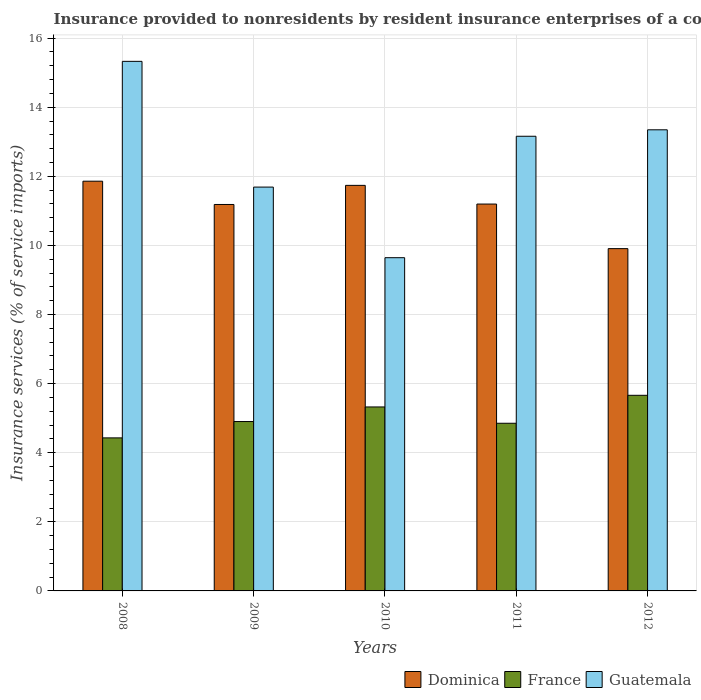How many different coloured bars are there?
Your answer should be compact. 3. How many groups of bars are there?
Provide a short and direct response. 5. Are the number of bars per tick equal to the number of legend labels?
Ensure brevity in your answer.  Yes. Are the number of bars on each tick of the X-axis equal?
Ensure brevity in your answer.  Yes. What is the insurance provided to nonresidents in Guatemala in 2008?
Make the answer very short. 15.33. Across all years, what is the maximum insurance provided to nonresidents in Dominica?
Provide a succinct answer. 11.86. Across all years, what is the minimum insurance provided to nonresidents in France?
Offer a very short reply. 4.43. In which year was the insurance provided to nonresidents in Guatemala maximum?
Your answer should be compact. 2008. In which year was the insurance provided to nonresidents in Dominica minimum?
Offer a very short reply. 2012. What is the total insurance provided to nonresidents in Dominica in the graph?
Your answer should be compact. 55.89. What is the difference between the insurance provided to nonresidents in Dominica in 2008 and that in 2011?
Your answer should be very brief. 0.66. What is the difference between the insurance provided to nonresidents in Dominica in 2008 and the insurance provided to nonresidents in Guatemala in 2012?
Provide a succinct answer. -1.49. What is the average insurance provided to nonresidents in Guatemala per year?
Your answer should be compact. 12.63. In the year 2010, what is the difference between the insurance provided to nonresidents in France and insurance provided to nonresidents in Dominica?
Provide a succinct answer. -6.41. What is the ratio of the insurance provided to nonresidents in Guatemala in 2011 to that in 2012?
Your response must be concise. 0.99. What is the difference between the highest and the second highest insurance provided to nonresidents in Dominica?
Offer a very short reply. 0.12. What is the difference between the highest and the lowest insurance provided to nonresidents in Guatemala?
Offer a terse response. 5.68. In how many years, is the insurance provided to nonresidents in Guatemala greater than the average insurance provided to nonresidents in Guatemala taken over all years?
Keep it short and to the point. 3. Is the sum of the insurance provided to nonresidents in Dominica in 2008 and 2011 greater than the maximum insurance provided to nonresidents in Guatemala across all years?
Give a very brief answer. Yes. What does the 3rd bar from the left in 2011 represents?
Your answer should be very brief. Guatemala. What does the 3rd bar from the right in 2011 represents?
Provide a short and direct response. Dominica. How many bars are there?
Offer a very short reply. 15. What is the difference between two consecutive major ticks on the Y-axis?
Make the answer very short. 2. Are the values on the major ticks of Y-axis written in scientific E-notation?
Keep it short and to the point. No. Does the graph contain any zero values?
Give a very brief answer. No. Where does the legend appear in the graph?
Your answer should be very brief. Bottom right. How many legend labels are there?
Your answer should be compact. 3. What is the title of the graph?
Your answer should be very brief. Insurance provided to nonresidents by resident insurance enterprises of a country. Does "Philippines" appear as one of the legend labels in the graph?
Offer a terse response. No. What is the label or title of the Y-axis?
Keep it short and to the point. Insurance services (% of service imports). What is the Insurance services (% of service imports) of Dominica in 2008?
Your response must be concise. 11.86. What is the Insurance services (% of service imports) of France in 2008?
Your answer should be very brief. 4.43. What is the Insurance services (% of service imports) of Guatemala in 2008?
Your response must be concise. 15.33. What is the Insurance services (% of service imports) of Dominica in 2009?
Your response must be concise. 11.19. What is the Insurance services (% of service imports) of France in 2009?
Provide a succinct answer. 4.9. What is the Insurance services (% of service imports) in Guatemala in 2009?
Offer a very short reply. 11.69. What is the Insurance services (% of service imports) of Dominica in 2010?
Make the answer very short. 11.74. What is the Insurance services (% of service imports) of France in 2010?
Your answer should be very brief. 5.32. What is the Insurance services (% of service imports) of Guatemala in 2010?
Ensure brevity in your answer.  9.65. What is the Insurance services (% of service imports) of Dominica in 2011?
Your response must be concise. 11.2. What is the Insurance services (% of service imports) of France in 2011?
Your answer should be very brief. 4.85. What is the Insurance services (% of service imports) in Guatemala in 2011?
Make the answer very short. 13.16. What is the Insurance services (% of service imports) in Dominica in 2012?
Offer a terse response. 9.91. What is the Insurance services (% of service imports) of France in 2012?
Keep it short and to the point. 5.66. What is the Insurance services (% of service imports) in Guatemala in 2012?
Ensure brevity in your answer.  13.35. Across all years, what is the maximum Insurance services (% of service imports) in Dominica?
Your response must be concise. 11.86. Across all years, what is the maximum Insurance services (% of service imports) in France?
Provide a succinct answer. 5.66. Across all years, what is the maximum Insurance services (% of service imports) of Guatemala?
Your answer should be very brief. 15.33. Across all years, what is the minimum Insurance services (% of service imports) in Dominica?
Your answer should be very brief. 9.91. Across all years, what is the minimum Insurance services (% of service imports) of France?
Your answer should be compact. 4.43. Across all years, what is the minimum Insurance services (% of service imports) of Guatemala?
Your answer should be compact. 9.65. What is the total Insurance services (% of service imports) in Dominica in the graph?
Give a very brief answer. 55.89. What is the total Insurance services (% of service imports) of France in the graph?
Ensure brevity in your answer.  25.17. What is the total Insurance services (% of service imports) in Guatemala in the graph?
Offer a terse response. 63.17. What is the difference between the Insurance services (% of service imports) in Dominica in 2008 and that in 2009?
Offer a very short reply. 0.67. What is the difference between the Insurance services (% of service imports) in France in 2008 and that in 2009?
Make the answer very short. -0.47. What is the difference between the Insurance services (% of service imports) in Guatemala in 2008 and that in 2009?
Provide a succinct answer. 3.64. What is the difference between the Insurance services (% of service imports) of Dominica in 2008 and that in 2010?
Your answer should be compact. 0.12. What is the difference between the Insurance services (% of service imports) of France in 2008 and that in 2010?
Provide a short and direct response. -0.9. What is the difference between the Insurance services (% of service imports) in Guatemala in 2008 and that in 2010?
Offer a terse response. 5.68. What is the difference between the Insurance services (% of service imports) in Dominica in 2008 and that in 2011?
Offer a very short reply. 0.66. What is the difference between the Insurance services (% of service imports) of France in 2008 and that in 2011?
Keep it short and to the point. -0.42. What is the difference between the Insurance services (% of service imports) in Guatemala in 2008 and that in 2011?
Your answer should be compact. 2.17. What is the difference between the Insurance services (% of service imports) in Dominica in 2008 and that in 2012?
Offer a very short reply. 1.95. What is the difference between the Insurance services (% of service imports) of France in 2008 and that in 2012?
Make the answer very short. -1.23. What is the difference between the Insurance services (% of service imports) in Guatemala in 2008 and that in 2012?
Give a very brief answer. 1.98. What is the difference between the Insurance services (% of service imports) of Dominica in 2009 and that in 2010?
Provide a short and direct response. -0.55. What is the difference between the Insurance services (% of service imports) in France in 2009 and that in 2010?
Offer a very short reply. -0.42. What is the difference between the Insurance services (% of service imports) in Guatemala in 2009 and that in 2010?
Your response must be concise. 2.04. What is the difference between the Insurance services (% of service imports) of Dominica in 2009 and that in 2011?
Your response must be concise. -0.01. What is the difference between the Insurance services (% of service imports) in France in 2009 and that in 2011?
Make the answer very short. 0.05. What is the difference between the Insurance services (% of service imports) in Guatemala in 2009 and that in 2011?
Give a very brief answer. -1.47. What is the difference between the Insurance services (% of service imports) in Dominica in 2009 and that in 2012?
Offer a very short reply. 1.28. What is the difference between the Insurance services (% of service imports) of France in 2009 and that in 2012?
Give a very brief answer. -0.76. What is the difference between the Insurance services (% of service imports) in Guatemala in 2009 and that in 2012?
Make the answer very short. -1.66. What is the difference between the Insurance services (% of service imports) in Dominica in 2010 and that in 2011?
Provide a short and direct response. 0.54. What is the difference between the Insurance services (% of service imports) of France in 2010 and that in 2011?
Your answer should be very brief. 0.47. What is the difference between the Insurance services (% of service imports) in Guatemala in 2010 and that in 2011?
Make the answer very short. -3.51. What is the difference between the Insurance services (% of service imports) in Dominica in 2010 and that in 2012?
Your response must be concise. 1.83. What is the difference between the Insurance services (% of service imports) of France in 2010 and that in 2012?
Offer a terse response. -0.34. What is the difference between the Insurance services (% of service imports) in Guatemala in 2010 and that in 2012?
Keep it short and to the point. -3.7. What is the difference between the Insurance services (% of service imports) in Dominica in 2011 and that in 2012?
Make the answer very short. 1.29. What is the difference between the Insurance services (% of service imports) in France in 2011 and that in 2012?
Offer a very short reply. -0.81. What is the difference between the Insurance services (% of service imports) in Guatemala in 2011 and that in 2012?
Your response must be concise. -0.19. What is the difference between the Insurance services (% of service imports) of Dominica in 2008 and the Insurance services (% of service imports) of France in 2009?
Provide a short and direct response. 6.96. What is the difference between the Insurance services (% of service imports) in Dominica in 2008 and the Insurance services (% of service imports) in Guatemala in 2009?
Make the answer very short. 0.17. What is the difference between the Insurance services (% of service imports) in France in 2008 and the Insurance services (% of service imports) in Guatemala in 2009?
Keep it short and to the point. -7.26. What is the difference between the Insurance services (% of service imports) in Dominica in 2008 and the Insurance services (% of service imports) in France in 2010?
Your response must be concise. 6.53. What is the difference between the Insurance services (% of service imports) of Dominica in 2008 and the Insurance services (% of service imports) of Guatemala in 2010?
Give a very brief answer. 2.21. What is the difference between the Insurance services (% of service imports) in France in 2008 and the Insurance services (% of service imports) in Guatemala in 2010?
Keep it short and to the point. -5.22. What is the difference between the Insurance services (% of service imports) of Dominica in 2008 and the Insurance services (% of service imports) of France in 2011?
Provide a short and direct response. 7.01. What is the difference between the Insurance services (% of service imports) of Dominica in 2008 and the Insurance services (% of service imports) of Guatemala in 2011?
Provide a succinct answer. -1.3. What is the difference between the Insurance services (% of service imports) in France in 2008 and the Insurance services (% of service imports) in Guatemala in 2011?
Make the answer very short. -8.73. What is the difference between the Insurance services (% of service imports) of Dominica in 2008 and the Insurance services (% of service imports) of France in 2012?
Make the answer very short. 6.2. What is the difference between the Insurance services (% of service imports) of Dominica in 2008 and the Insurance services (% of service imports) of Guatemala in 2012?
Provide a short and direct response. -1.49. What is the difference between the Insurance services (% of service imports) in France in 2008 and the Insurance services (% of service imports) in Guatemala in 2012?
Provide a succinct answer. -8.92. What is the difference between the Insurance services (% of service imports) of Dominica in 2009 and the Insurance services (% of service imports) of France in 2010?
Your answer should be very brief. 5.86. What is the difference between the Insurance services (% of service imports) in Dominica in 2009 and the Insurance services (% of service imports) in Guatemala in 2010?
Give a very brief answer. 1.54. What is the difference between the Insurance services (% of service imports) of France in 2009 and the Insurance services (% of service imports) of Guatemala in 2010?
Provide a succinct answer. -4.74. What is the difference between the Insurance services (% of service imports) in Dominica in 2009 and the Insurance services (% of service imports) in France in 2011?
Make the answer very short. 6.33. What is the difference between the Insurance services (% of service imports) of Dominica in 2009 and the Insurance services (% of service imports) of Guatemala in 2011?
Your response must be concise. -1.97. What is the difference between the Insurance services (% of service imports) of France in 2009 and the Insurance services (% of service imports) of Guatemala in 2011?
Your answer should be very brief. -8.26. What is the difference between the Insurance services (% of service imports) in Dominica in 2009 and the Insurance services (% of service imports) in France in 2012?
Your answer should be compact. 5.52. What is the difference between the Insurance services (% of service imports) of Dominica in 2009 and the Insurance services (% of service imports) of Guatemala in 2012?
Offer a terse response. -2.16. What is the difference between the Insurance services (% of service imports) in France in 2009 and the Insurance services (% of service imports) in Guatemala in 2012?
Give a very brief answer. -8.44. What is the difference between the Insurance services (% of service imports) in Dominica in 2010 and the Insurance services (% of service imports) in France in 2011?
Give a very brief answer. 6.89. What is the difference between the Insurance services (% of service imports) of Dominica in 2010 and the Insurance services (% of service imports) of Guatemala in 2011?
Keep it short and to the point. -1.42. What is the difference between the Insurance services (% of service imports) in France in 2010 and the Insurance services (% of service imports) in Guatemala in 2011?
Make the answer very short. -7.83. What is the difference between the Insurance services (% of service imports) in Dominica in 2010 and the Insurance services (% of service imports) in France in 2012?
Keep it short and to the point. 6.08. What is the difference between the Insurance services (% of service imports) in Dominica in 2010 and the Insurance services (% of service imports) in Guatemala in 2012?
Offer a terse response. -1.61. What is the difference between the Insurance services (% of service imports) of France in 2010 and the Insurance services (% of service imports) of Guatemala in 2012?
Your answer should be compact. -8.02. What is the difference between the Insurance services (% of service imports) of Dominica in 2011 and the Insurance services (% of service imports) of France in 2012?
Your response must be concise. 5.54. What is the difference between the Insurance services (% of service imports) of Dominica in 2011 and the Insurance services (% of service imports) of Guatemala in 2012?
Your response must be concise. -2.15. What is the difference between the Insurance services (% of service imports) of France in 2011 and the Insurance services (% of service imports) of Guatemala in 2012?
Provide a succinct answer. -8.49. What is the average Insurance services (% of service imports) of Dominica per year?
Make the answer very short. 11.18. What is the average Insurance services (% of service imports) in France per year?
Offer a very short reply. 5.03. What is the average Insurance services (% of service imports) in Guatemala per year?
Your answer should be compact. 12.63. In the year 2008, what is the difference between the Insurance services (% of service imports) of Dominica and Insurance services (% of service imports) of France?
Your answer should be compact. 7.43. In the year 2008, what is the difference between the Insurance services (% of service imports) in Dominica and Insurance services (% of service imports) in Guatemala?
Your answer should be compact. -3.47. In the year 2008, what is the difference between the Insurance services (% of service imports) in France and Insurance services (% of service imports) in Guatemala?
Your answer should be very brief. -10.9. In the year 2009, what is the difference between the Insurance services (% of service imports) of Dominica and Insurance services (% of service imports) of France?
Your answer should be very brief. 6.28. In the year 2009, what is the difference between the Insurance services (% of service imports) in Dominica and Insurance services (% of service imports) in Guatemala?
Offer a very short reply. -0.5. In the year 2009, what is the difference between the Insurance services (% of service imports) in France and Insurance services (% of service imports) in Guatemala?
Provide a short and direct response. -6.79. In the year 2010, what is the difference between the Insurance services (% of service imports) of Dominica and Insurance services (% of service imports) of France?
Your answer should be very brief. 6.41. In the year 2010, what is the difference between the Insurance services (% of service imports) of Dominica and Insurance services (% of service imports) of Guatemala?
Your answer should be compact. 2.09. In the year 2010, what is the difference between the Insurance services (% of service imports) of France and Insurance services (% of service imports) of Guatemala?
Your answer should be compact. -4.32. In the year 2011, what is the difference between the Insurance services (% of service imports) in Dominica and Insurance services (% of service imports) in France?
Offer a very short reply. 6.34. In the year 2011, what is the difference between the Insurance services (% of service imports) of Dominica and Insurance services (% of service imports) of Guatemala?
Your response must be concise. -1.96. In the year 2011, what is the difference between the Insurance services (% of service imports) in France and Insurance services (% of service imports) in Guatemala?
Offer a terse response. -8.31. In the year 2012, what is the difference between the Insurance services (% of service imports) of Dominica and Insurance services (% of service imports) of France?
Offer a terse response. 4.25. In the year 2012, what is the difference between the Insurance services (% of service imports) in Dominica and Insurance services (% of service imports) in Guatemala?
Offer a very short reply. -3.44. In the year 2012, what is the difference between the Insurance services (% of service imports) of France and Insurance services (% of service imports) of Guatemala?
Make the answer very short. -7.68. What is the ratio of the Insurance services (% of service imports) of Dominica in 2008 to that in 2009?
Your answer should be very brief. 1.06. What is the ratio of the Insurance services (% of service imports) in France in 2008 to that in 2009?
Offer a very short reply. 0.9. What is the ratio of the Insurance services (% of service imports) in Guatemala in 2008 to that in 2009?
Offer a very short reply. 1.31. What is the ratio of the Insurance services (% of service imports) of Dominica in 2008 to that in 2010?
Offer a terse response. 1.01. What is the ratio of the Insurance services (% of service imports) of France in 2008 to that in 2010?
Provide a succinct answer. 0.83. What is the ratio of the Insurance services (% of service imports) of Guatemala in 2008 to that in 2010?
Keep it short and to the point. 1.59. What is the ratio of the Insurance services (% of service imports) in Dominica in 2008 to that in 2011?
Your response must be concise. 1.06. What is the ratio of the Insurance services (% of service imports) of France in 2008 to that in 2011?
Make the answer very short. 0.91. What is the ratio of the Insurance services (% of service imports) in Guatemala in 2008 to that in 2011?
Provide a succinct answer. 1.16. What is the ratio of the Insurance services (% of service imports) of Dominica in 2008 to that in 2012?
Provide a short and direct response. 1.2. What is the ratio of the Insurance services (% of service imports) in France in 2008 to that in 2012?
Your answer should be very brief. 0.78. What is the ratio of the Insurance services (% of service imports) of Guatemala in 2008 to that in 2012?
Offer a very short reply. 1.15. What is the ratio of the Insurance services (% of service imports) of Dominica in 2009 to that in 2010?
Provide a succinct answer. 0.95. What is the ratio of the Insurance services (% of service imports) of France in 2009 to that in 2010?
Keep it short and to the point. 0.92. What is the ratio of the Insurance services (% of service imports) in Guatemala in 2009 to that in 2010?
Provide a succinct answer. 1.21. What is the ratio of the Insurance services (% of service imports) of Dominica in 2009 to that in 2011?
Ensure brevity in your answer.  1. What is the ratio of the Insurance services (% of service imports) in France in 2009 to that in 2011?
Offer a terse response. 1.01. What is the ratio of the Insurance services (% of service imports) in Guatemala in 2009 to that in 2011?
Your response must be concise. 0.89. What is the ratio of the Insurance services (% of service imports) in Dominica in 2009 to that in 2012?
Provide a succinct answer. 1.13. What is the ratio of the Insurance services (% of service imports) in France in 2009 to that in 2012?
Your answer should be compact. 0.87. What is the ratio of the Insurance services (% of service imports) of Guatemala in 2009 to that in 2012?
Make the answer very short. 0.88. What is the ratio of the Insurance services (% of service imports) in Dominica in 2010 to that in 2011?
Your answer should be compact. 1.05. What is the ratio of the Insurance services (% of service imports) in France in 2010 to that in 2011?
Ensure brevity in your answer.  1.1. What is the ratio of the Insurance services (% of service imports) in Guatemala in 2010 to that in 2011?
Provide a short and direct response. 0.73. What is the ratio of the Insurance services (% of service imports) of Dominica in 2010 to that in 2012?
Your response must be concise. 1.18. What is the ratio of the Insurance services (% of service imports) in France in 2010 to that in 2012?
Offer a terse response. 0.94. What is the ratio of the Insurance services (% of service imports) in Guatemala in 2010 to that in 2012?
Provide a short and direct response. 0.72. What is the ratio of the Insurance services (% of service imports) of Dominica in 2011 to that in 2012?
Give a very brief answer. 1.13. What is the difference between the highest and the second highest Insurance services (% of service imports) in Dominica?
Your answer should be very brief. 0.12. What is the difference between the highest and the second highest Insurance services (% of service imports) in France?
Make the answer very short. 0.34. What is the difference between the highest and the second highest Insurance services (% of service imports) in Guatemala?
Ensure brevity in your answer.  1.98. What is the difference between the highest and the lowest Insurance services (% of service imports) of Dominica?
Ensure brevity in your answer.  1.95. What is the difference between the highest and the lowest Insurance services (% of service imports) of France?
Your answer should be very brief. 1.23. What is the difference between the highest and the lowest Insurance services (% of service imports) of Guatemala?
Make the answer very short. 5.68. 